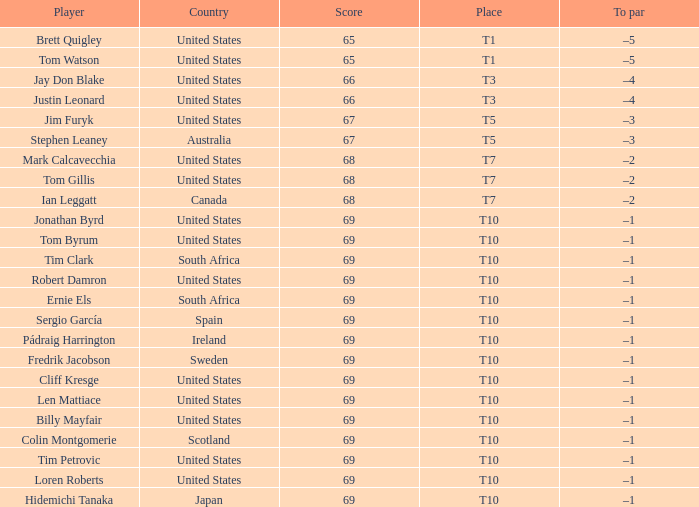What is Tom Gillis' score? 68.0. 